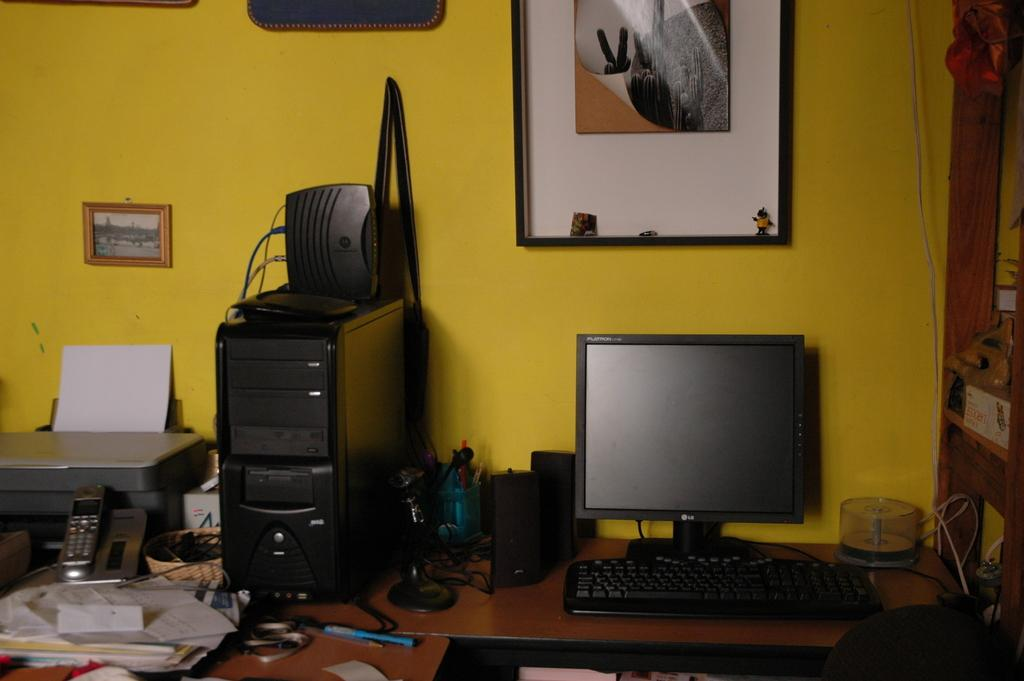What electronic device is visible in the image? There is a computer in the image. What device might be used for amplifying sound in the image? There is a loudspeaker in the image. What is hanging on the wall in the image? There is a frame on the wall in the image. What is being prepared for copying in the image? There is a paper on a xerox machine in the image. What writing instrument is on the table in the image? There is a pen on a table in the image. What type of fruit is being used as a decoration in the image? There is no fruit present in the image; it features a computer, loudspeaker, frame, paper on a xerox machine, and pen on a table. What is the heart rate of the person in the image? There is no person present in the image, so it is not possible to determine their heart rate. 